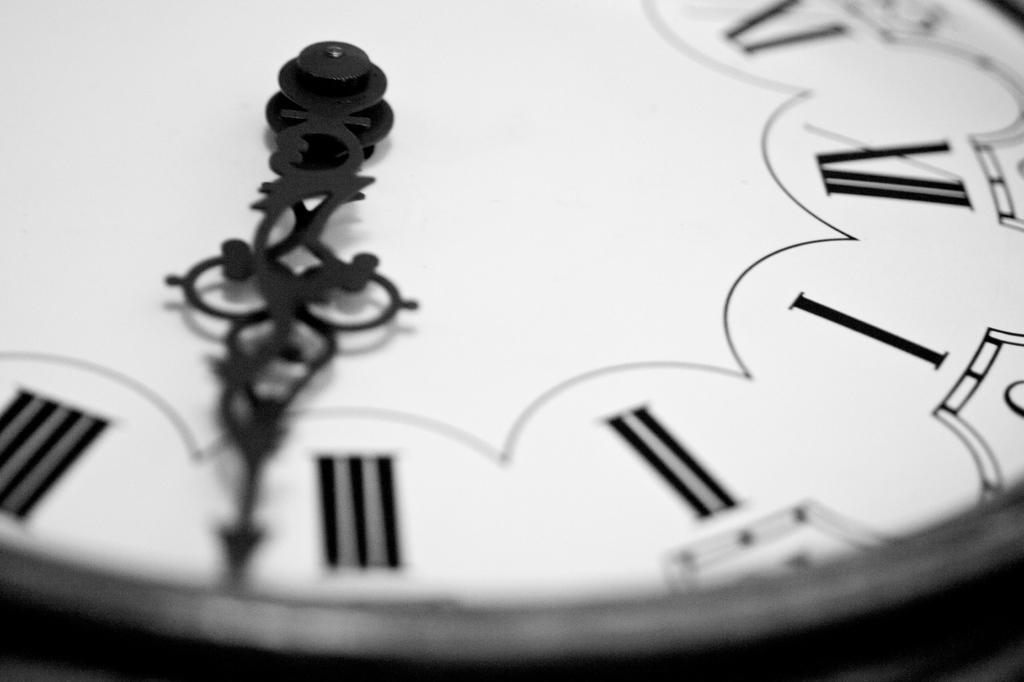<image>
Render a clear and concise summary of the photo. The close up of the clock face shows both hands at just past the roman numeral III. 